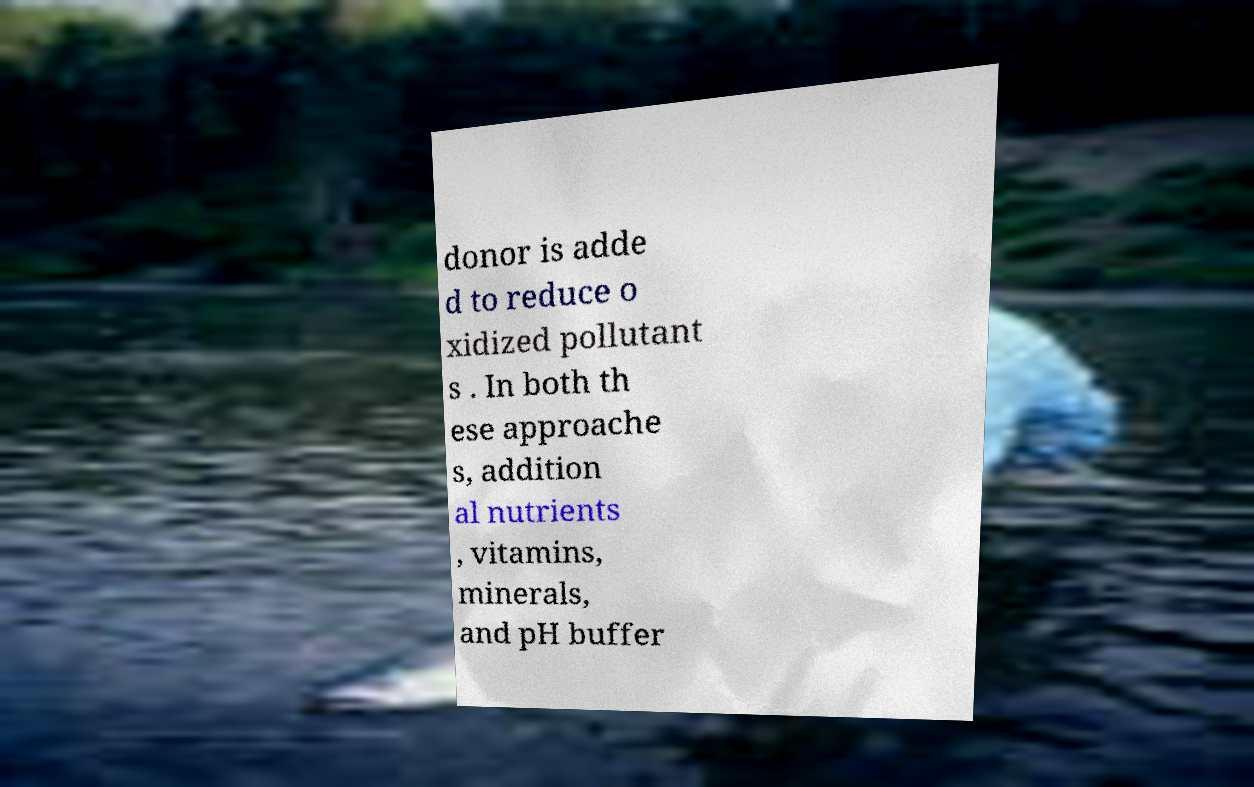What messages or text are displayed in this image? I need them in a readable, typed format. donor is adde d to reduce o xidized pollutant s . In both th ese approache s, addition al nutrients , vitamins, minerals, and pH buffer 